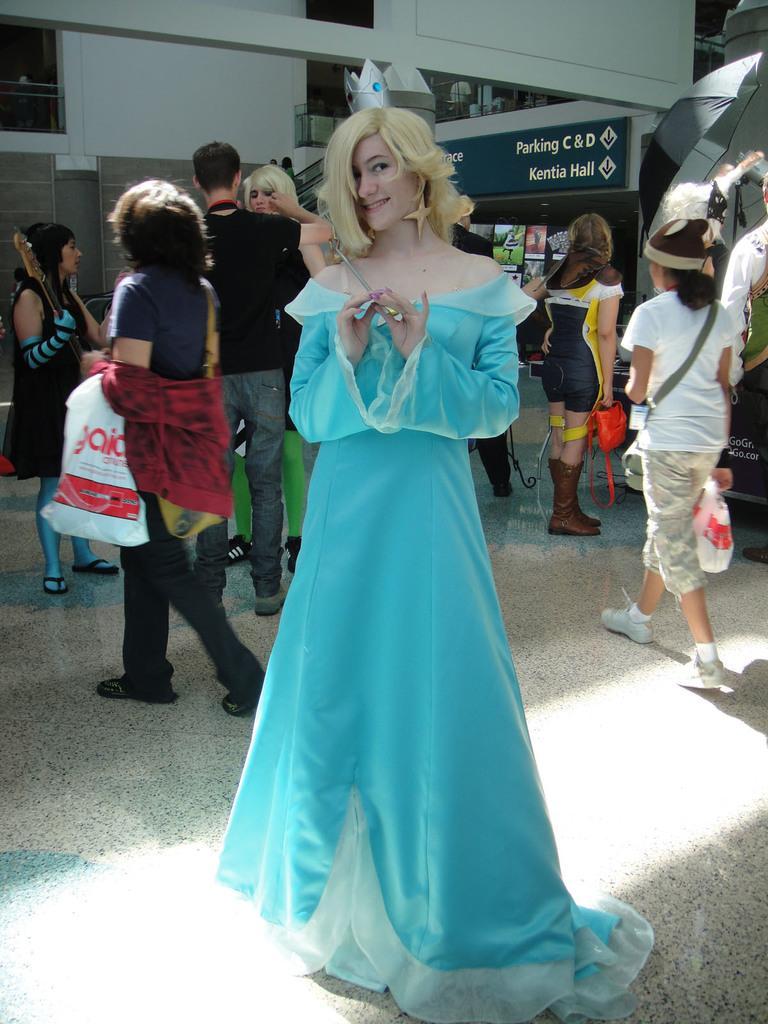Can you describe this image briefly? In this image I can see number of people are standing. I can also see few people are holding bags and few people are wearing costumes. In the background I can see an umbrella, a board and on it I can see something is written. 